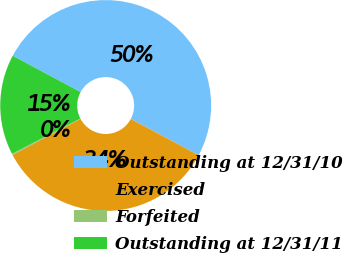Convert chart to OTSL. <chart><loc_0><loc_0><loc_500><loc_500><pie_chart><fcel>Outstanding at 12/31/10<fcel>Exercised<fcel>Forfeited<fcel>Outstanding at 12/31/11<nl><fcel>50.0%<fcel>34.42%<fcel>0.19%<fcel>15.39%<nl></chart> 